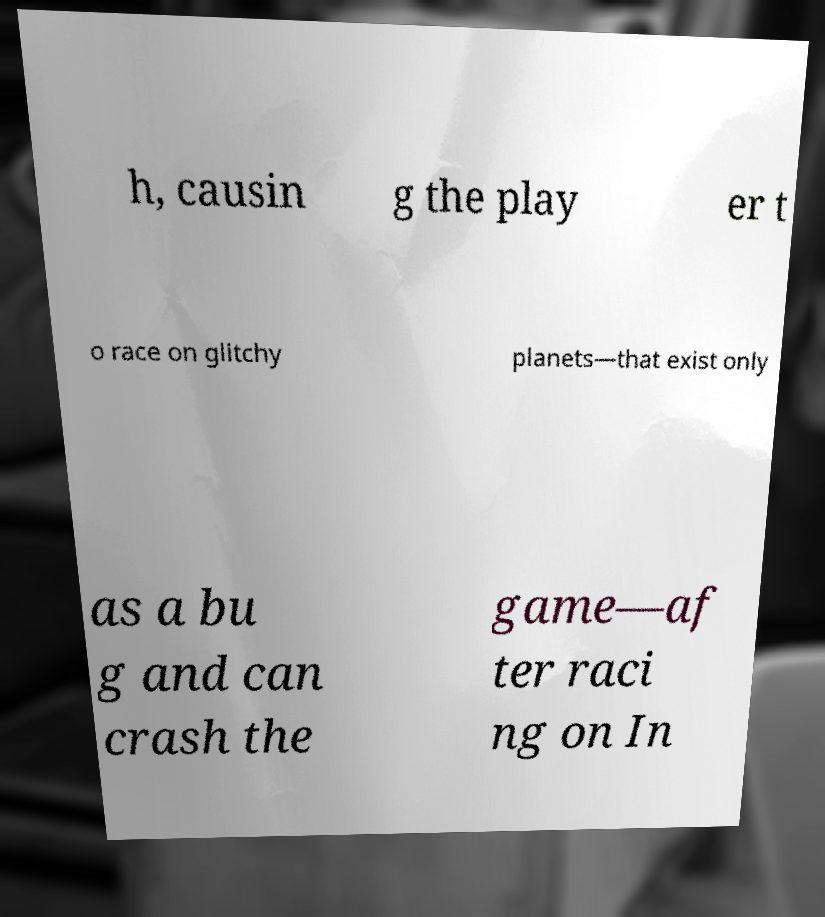For documentation purposes, I need the text within this image transcribed. Could you provide that? h, causin g the play er t o race on glitchy planets—that exist only as a bu g and can crash the game—af ter raci ng on In 